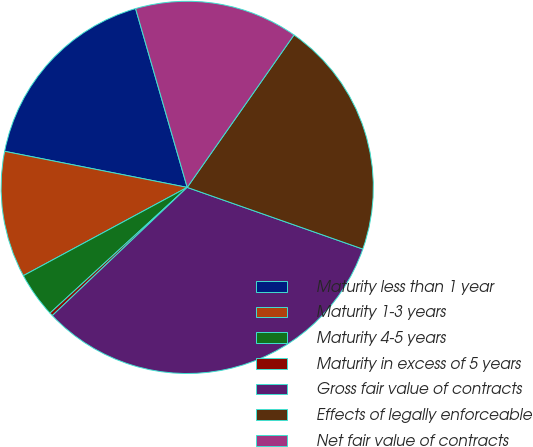Convert chart. <chart><loc_0><loc_0><loc_500><loc_500><pie_chart><fcel>Maturity less than 1 year<fcel>Maturity 1-3 years<fcel>Maturity 4-5 years<fcel>Maturity in excess of 5 years<fcel>Gross fair value of contracts<fcel>Effects of legally enforceable<fcel>Net fair value of contracts<nl><fcel>17.42%<fcel>10.97%<fcel>3.94%<fcel>0.29%<fcel>32.53%<fcel>20.65%<fcel>14.2%<nl></chart> 